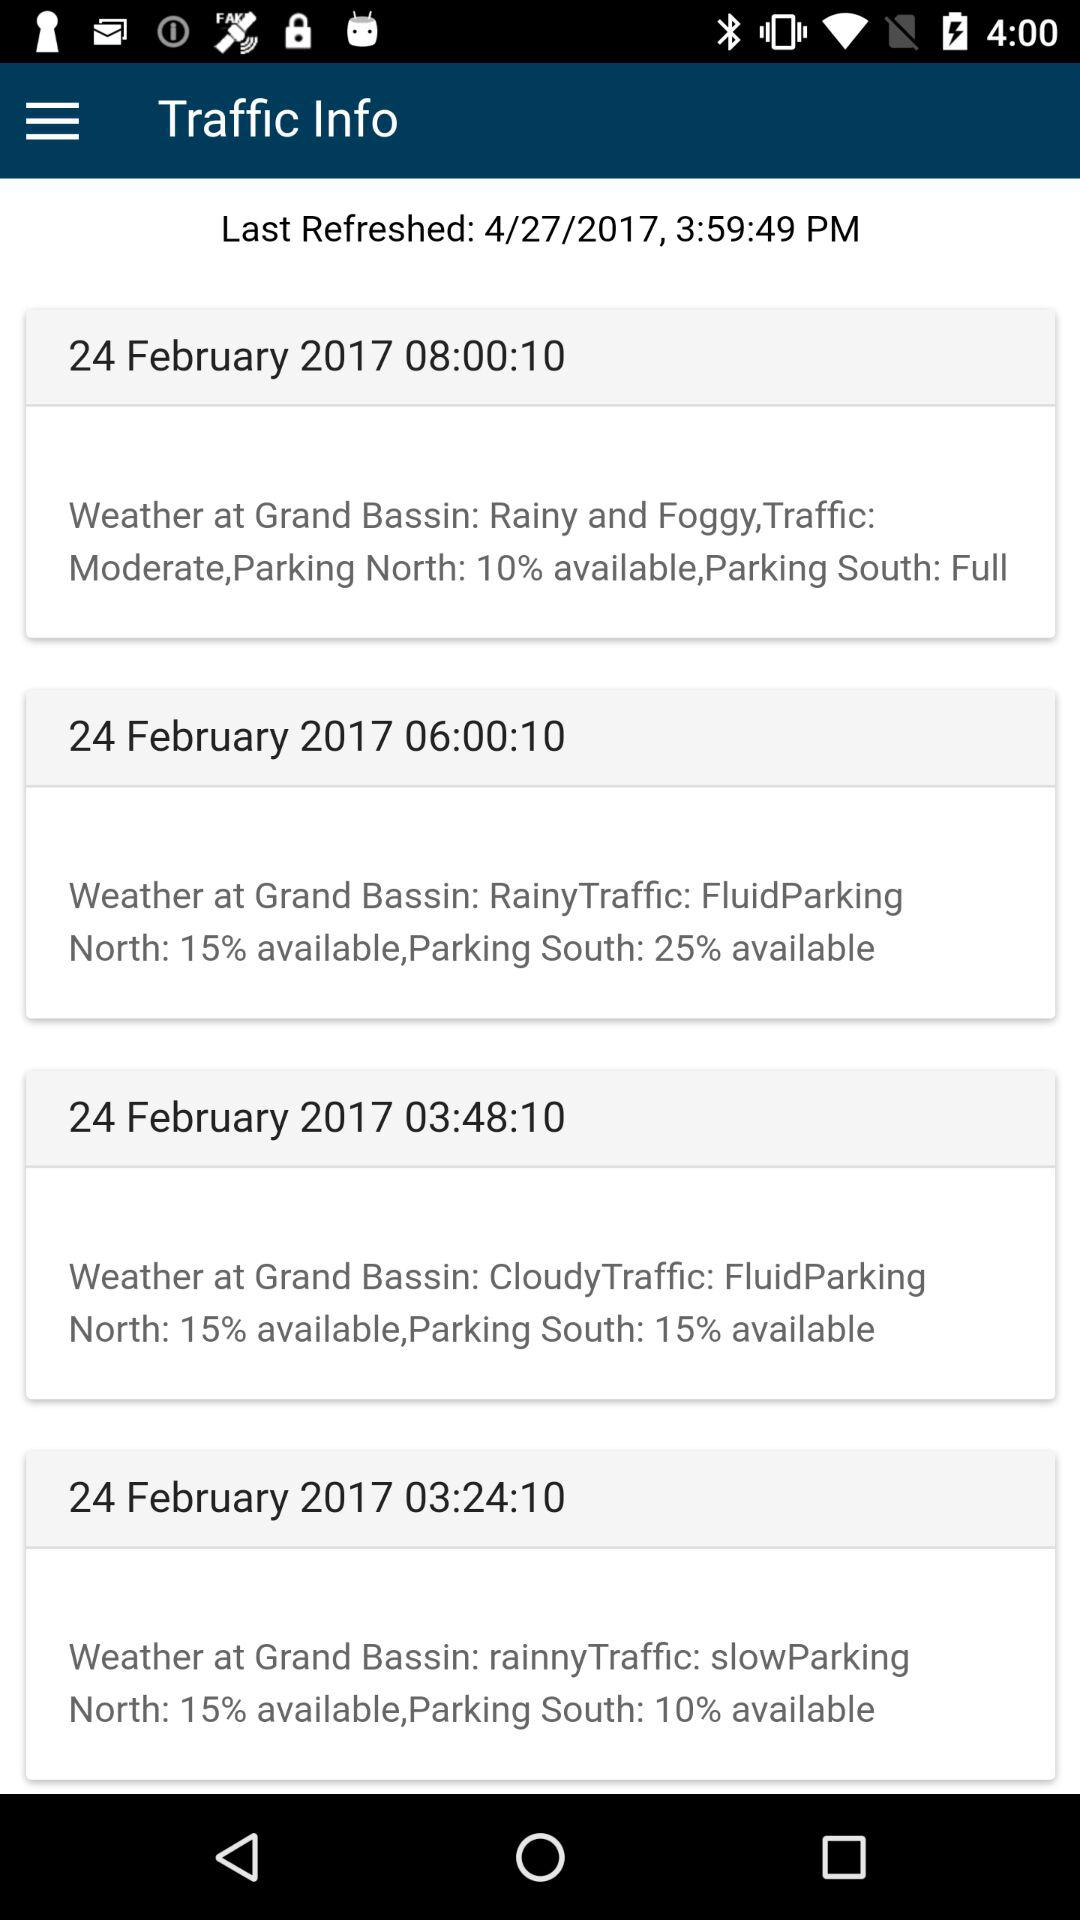At what time was the south parking full? The south parking was full at 08:00:10. 